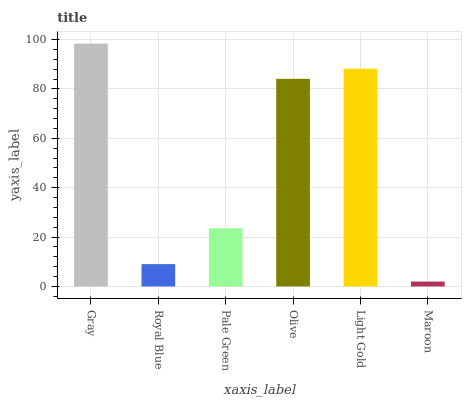Is Maroon the minimum?
Answer yes or no. Yes. Is Gray the maximum?
Answer yes or no. Yes. Is Royal Blue the minimum?
Answer yes or no. No. Is Royal Blue the maximum?
Answer yes or no. No. Is Gray greater than Royal Blue?
Answer yes or no. Yes. Is Royal Blue less than Gray?
Answer yes or no. Yes. Is Royal Blue greater than Gray?
Answer yes or no. No. Is Gray less than Royal Blue?
Answer yes or no. No. Is Olive the high median?
Answer yes or no. Yes. Is Pale Green the low median?
Answer yes or no. Yes. Is Light Gold the high median?
Answer yes or no. No. Is Gray the low median?
Answer yes or no. No. 